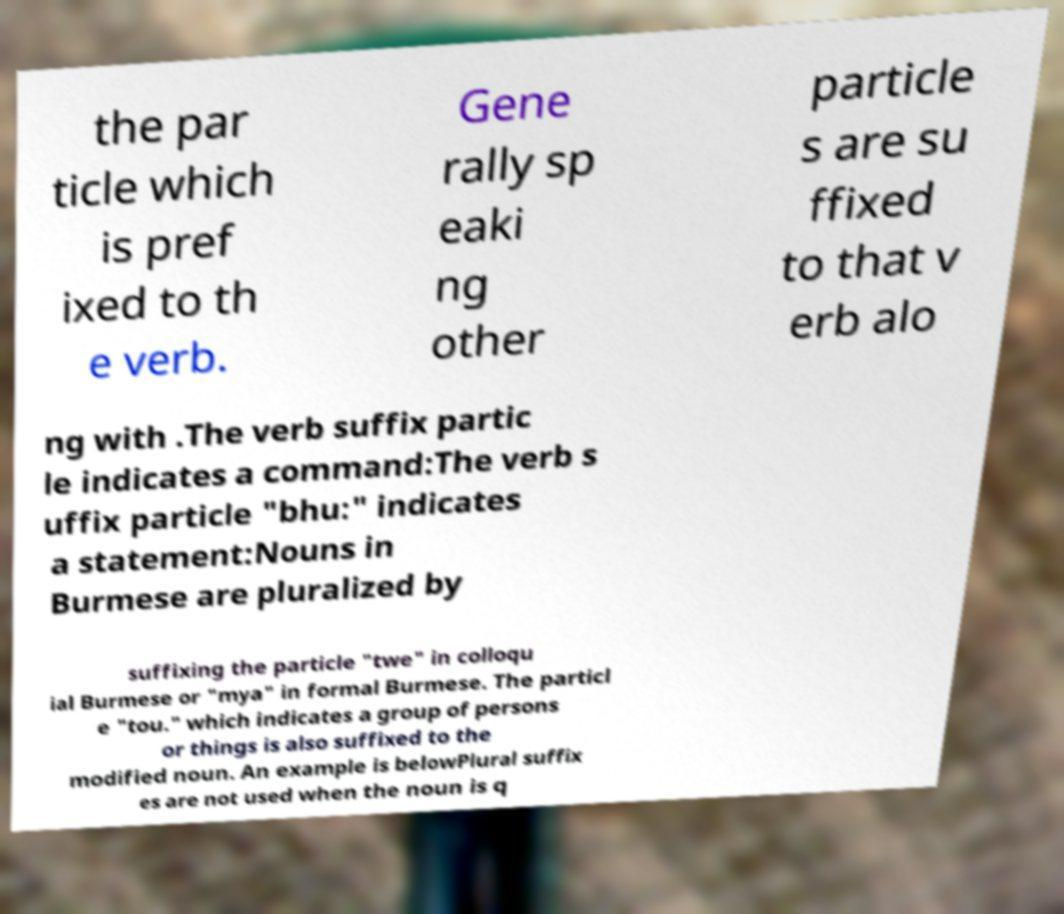Could you extract and type out the text from this image? the par ticle which is pref ixed to th e verb. Gene rally sp eaki ng other particle s are su ffixed to that v erb alo ng with .The verb suffix partic le indicates a command:The verb s uffix particle "bhu:" indicates a statement:Nouns in Burmese are pluralized by suffixing the particle "twe" in colloqu ial Burmese or "mya" in formal Burmese. The particl e "tou." which indicates a group of persons or things is also suffixed to the modified noun. An example is belowPlural suffix es are not used when the noun is q 